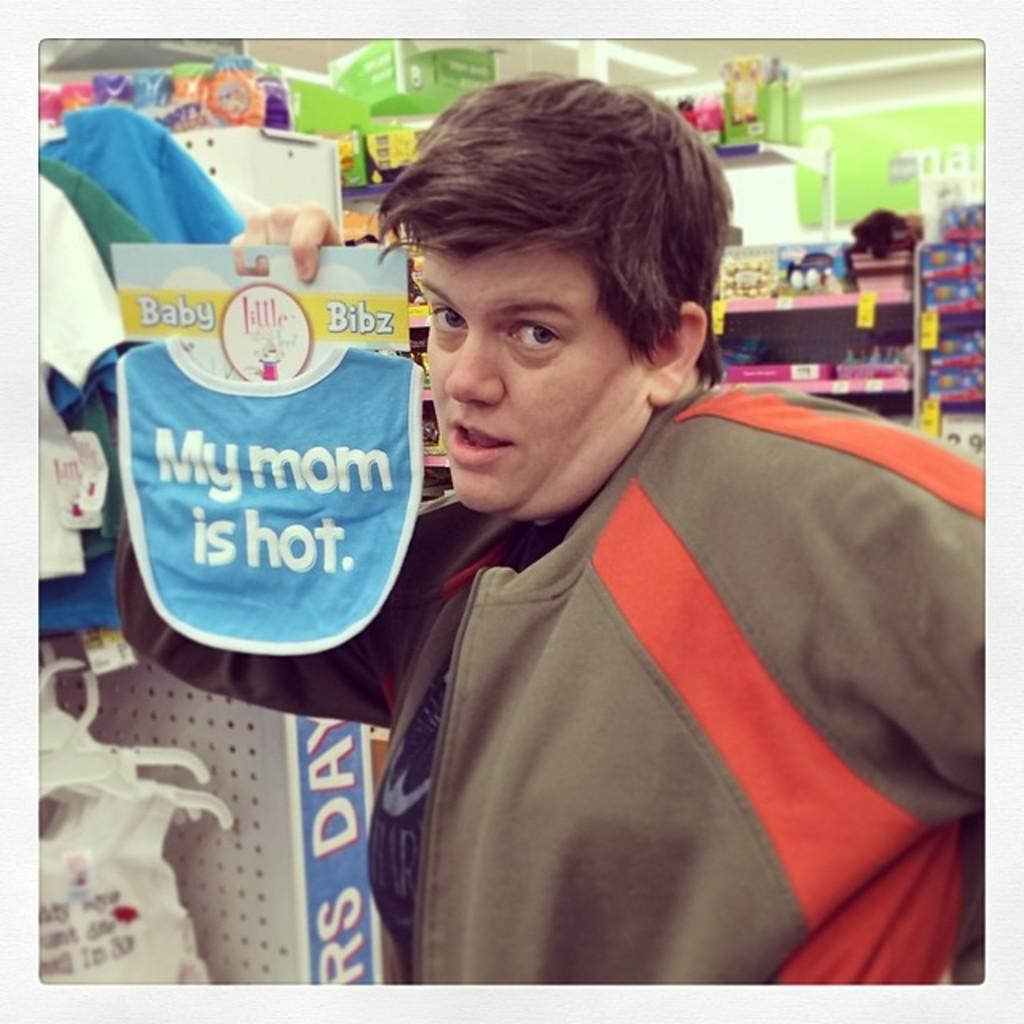<image>
Write a terse but informative summary of the picture. A man holding up a baby bib that says My Mom is Hot. 